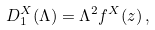Convert formula to latex. <formula><loc_0><loc_0><loc_500><loc_500>D _ { 1 } ^ { X } ( \Lambda ) = \Lambda ^ { 2 } f ^ { X } ( z ) \, ,</formula> 